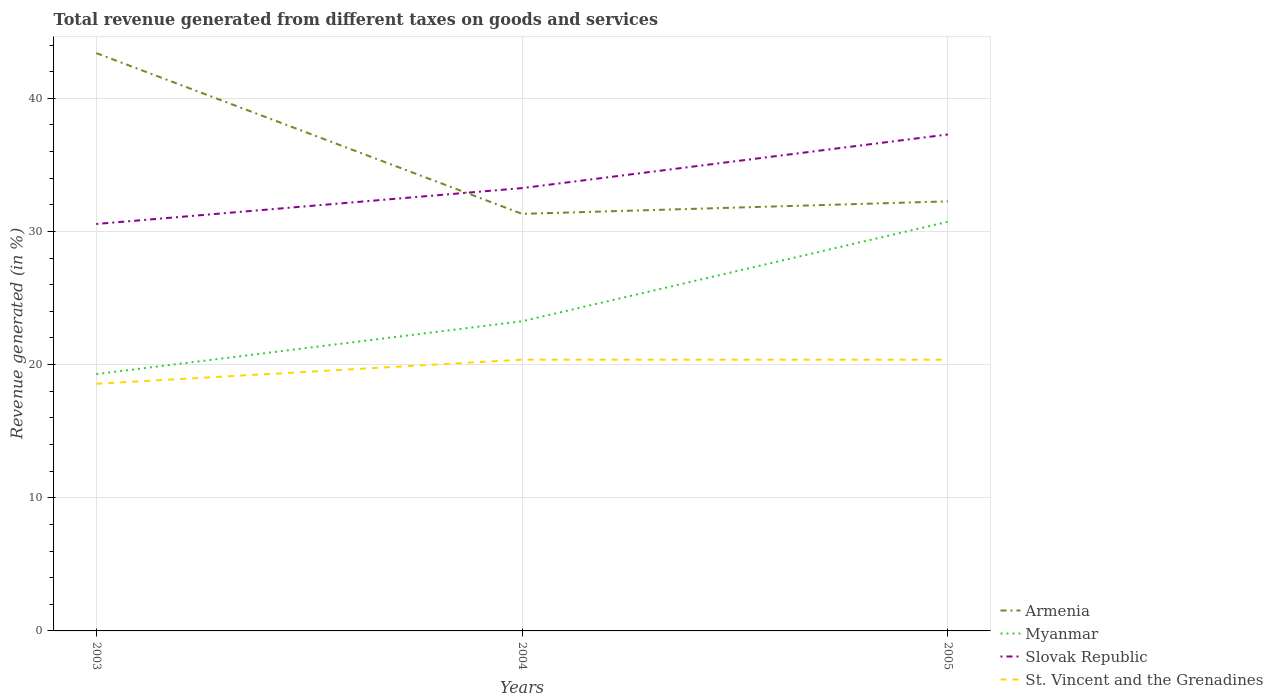Does the line corresponding to Slovak Republic intersect with the line corresponding to Myanmar?
Your response must be concise. No. Across all years, what is the maximum total revenue generated in Armenia?
Provide a succinct answer. 31.32. In which year was the total revenue generated in Myanmar maximum?
Make the answer very short. 2003. What is the total total revenue generated in Armenia in the graph?
Ensure brevity in your answer.  -0.94. What is the difference between the highest and the second highest total revenue generated in Slovak Republic?
Offer a very short reply. 6.72. What is the difference between the highest and the lowest total revenue generated in Myanmar?
Offer a terse response. 1. How many lines are there?
Ensure brevity in your answer.  4. How many years are there in the graph?
Make the answer very short. 3. Does the graph contain any zero values?
Make the answer very short. No. Where does the legend appear in the graph?
Your response must be concise. Bottom right. How are the legend labels stacked?
Offer a very short reply. Vertical. What is the title of the graph?
Provide a short and direct response. Total revenue generated from different taxes on goods and services. What is the label or title of the Y-axis?
Ensure brevity in your answer.  Revenue generated (in %). What is the Revenue generated (in %) of Armenia in 2003?
Your response must be concise. 43.39. What is the Revenue generated (in %) of Myanmar in 2003?
Keep it short and to the point. 19.29. What is the Revenue generated (in %) of Slovak Republic in 2003?
Give a very brief answer. 30.56. What is the Revenue generated (in %) in St. Vincent and the Grenadines in 2003?
Your answer should be compact. 18.56. What is the Revenue generated (in %) in Armenia in 2004?
Give a very brief answer. 31.32. What is the Revenue generated (in %) of Myanmar in 2004?
Your answer should be compact. 23.26. What is the Revenue generated (in %) in Slovak Republic in 2004?
Provide a short and direct response. 33.26. What is the Revenue generated (in %) in St. Vincent and the Grenadines in 2004?
Ensure brevity in your answer.  20.37. What is the Revenue generated (in %) in Armenia in 2005?
Your response must be concise. 32.26. What is the Revenue generated (in %) of Myanmar in 2005?
Offer a very short reply. 30.73. What is the Revenue generated (in %) in Slovak Republic in 2005?
Offer a very short reply. 37.28. What is the Revenue generated (in %) in St. Vincent and the Grenadines in 2005?
Offer a terse response. 20.37. Across all years, what is the maximum Revenue generated (in %) in Armenia?
Provide a succinct answer. 43.39. Across all years, what is the maximum Revenue generated (in %) of Myanmar?
Make the answer very short. 30.73. Across all years, what is the maximum Revenue generated (in %) in Slovak Republic?
Your answer should be compact. 37.28. Across all years, what is the maximum Revenue generated (in %) of St. Vincent and the Grenadines?
Provide a short and direct response. 20.37. Across all years, what is the minimum Revenue generated (in %) in Armenia?
Ensure brevity in your answer.  31.32. Across all years, what is the minimum Revenue generated (in %) in Myanmar?
Offer a terse response. 19.29. Across all years, what is the minimum Revenue generated (in %) in Slovak Republic?
Your answer should be very brief. 30.56. Across all years, what is the minimum Revenue generated (in %) of St. Vincent and the Grenadines?
Provide a short and direct response. 18.56. What is the total Revenue generated (in %) of Armenia in the graph?
Your answer should be very brief. 106.98. What is the total Revenue generated (in %) in Myanmar in the graph?
Your response must be concise. 73.27. What is the total Revenue generated (in %) in Slovak Republic in the graph?
Provide a short and direct response. 101.1. What is the total Revenue generated (in %) of St. Vincent and the Grenadines in the graph?
Your response must be concise. 59.3. What is the difference between the Revenue generated (in %) in Armenia in 2003 and that in 2004?
Keep it short and to the point. 12.07. What is the difference between the Revenue generated (in %) of Myanmar in 2003 and that in 2004?
Your answer should be very brief. -3.97. What is the difference between the Revenue generated (in %) of Slovak Republic in 2003 and that in 2004?
Your answer should be compact. -2.7. What is the difference between the Revenue generated (in %) of St. Vincent and the Grenadines in 2003 and that in 2004?
Ensure brevity in your answer.  -1.81. What is the difference between the Revenue generated (in %) of Armenia in 2003 and that in 2005?
Give a very brief answer. 11.13. What is the difference between the Revenue generated (in %) of Myanmar in 2003 and that in 2005?
Ensure brevity in your answer.  -11.44. What is the difference between the Revenue generated (in %) of Slovak Republic in 2003 and that in 2005?
Provide a short and direct response. -6.72. What is the difference between the Revenue generated (in %) of St. Vincent and the Grenadines in 2003 and that in 2005?
Give a very brief answer. -1.81. What is the difference between the Revenue generated (in %) in Armenia in 2004 and that in 2005?
Make the answer very short. -0.94. What is the difference between the Revenue generated (in %) of Myanmar in 2004 and that in 2005?
Provide a short and direct response. -7.47. What is the difference between the Revenue generated (in %) in Slovak Republic in 2004 and that in 2005?
Offer a terse response. -4.03. What is the difference between the Revenue generated (in %) in St. Vincent and the Grenadines in 2004 and that in 2005?
Make the answer very short. 0. What is the difference between the Revenue generated (in %) of Armenia in 2003 and the Revenue generated (in %) of Myanmar in 2004?
Make the answer very short. 20.14. What is the difference between the Revenue generated (in %) of Armenia in 2003 and the Revenue generated (in %) of Slovak Republic in 2004?
Your answer should be very brief. 10.14. What is the difference between the Revenue generated (in %) in Armenia in 2003 and the Revenue generated (in %) in St. Vincent and the Grenadines in 2004?
Offer a terse response. 23.02. What is the difference between the Revenue generated (in %) of Myanmar in 2003 and the Revenue generated (in %) of Slovak Republic in 2004?
Ensure brevity in your answer.  -13.97. What is the difference between the Revenue generated (in %) of Myanmar in 2003 and the Revenue generated (in %) of St. Vincent and the Grenadines in 2004?
Your answer should be compact. -1.08. What is the difference between the Revenue generated (in %) of Slovak Republic in 2003 and the Revenue generated (in %) of St. Vincent and the Grenadines in 2004?
Provide a short and direct response. 10.19. What is the difference between the Revenue generated (in %) of Armenia in 2003 and the Revenue generated (in %) of Myanmar in 2005?
Offer a very short reply. 12.67. What is the difference between the Revenue generated (in %) in Armenia in 2003 and the Revenue generated (in %) in Slovak Republic in 2005?
Your response must be concise. 6.11. What is the difference between the Revenue generated (in %) in Armenia in 2003 and the Revenue generated (in %) in St. Vincent and the Grenadines in 2005?
Make the answer very short. 23.02. What is the difference between the Revenue generated (in %) of Myanmar in 2003 and the Revenue generated (in %) of Slovak Republic in 2005?
Your answer should be very brief. -18. What is the difference between the Revenue generated (in %) in Myanmar in 2003 and the Revenue generated (in %) in St. Vincent and the Grenadines in 2005?
Make the answer very short. -1.08. What is the difference between the Revenue generated (in %) in Slovak Republic in 2003 and the Revenue generated (in %) in St. Vincent and the Grenadines in 2005?
Your answer should be compact. 10.19. What is the difference between the Revenue generated (in %) of Armenia in 2004 and the Revenue generated (in %) of Myanmar in 2005?
Provide a succinct answer. 0.59. What is the difference between the Revenue generated (in %) of Armenia in 2004 and the Revenue generated (in %) of Slovak Republic in 2005?
Offer a very short reply. -5.96. What is the difference between the Revenue generated (in %) of Armenia in 2004 and the Revenue generated (in %) of St. Vincent and the Grenadines in 2005?
Make the answer very short. 10.95. What is the difference between the Revenue generated (in %) of Myanmar in 2004 and the Revenue generated (in %) of Slovak Republic in 2005?
Your response must be concise. -14.03. What is the difference between the Revenue generated (in %) in Myanmar in 2004 and the Revenue generated (in %) in St. Vincent and the Grenadines in 2005?
Make the answer very short. 2.89. What is the difference between the Revenue generated (in %) in Slovak Republic in 2004 and the Revenue generated (in %) in St. Vincent and the Grenadines in 2005?
Keep it short and to the point. 12.89. What is the average Revenue generated (in %) in Armenia per year?
Provide a short and direct response. 35.66. What is the average Revenue generated (in %) of Myanmar per year?
Give a very brief answer. 24.42. What is the average Revenue generated (in %) in Slovak Republic per year?
Give a very brief answer. 33.7. What is the average Revenue generated (in %) of St. Vincent and the Grenadines per year?
Provide a short and direct response. 19.77. In the year 2003, what is the difference between the Revenue generated (in %) of Armenia and Revenue generated (in %) of Myanmar?
Your answer should be very brief. 24.11. In the year 2003, what is the difference between the Revenue generated (in %) in Armenia and Revenue generated (in %) in Slovak Republic?
Provide a succinct answer. 12.83. In the year 2003, what is the difference between the Revenue generated (in %) of Armenia and Revenue generated (in %) of St. Vincent and the Grenadines?
Your answer should be compact. 24.83. In the year 2003, what is the difference between the Revenue generated (in %) of Myanmar and Revenue generated (in %) of Slovak Republic?
Provide a short and direct response. -11.27. In the year 2003, what is the difference between the Revenue generated (in %) of Myanmar and Revenue generated (in %) of St. Vincent and the Grenadines?
Give a very brief answer. 0.73. In the year 2003, what is the difference between the Revenue generated (in %) in Slovak Republic and Revenue generated (in %) in St. Vincent and the Grenadines?
Give a very brief answer. 12. In the year 2004, what is the difference between the Revenue generated (in %) in Armenia and Revenue generated (in %) in Myanmar?
Make the answer very short. 8.06. In the year 2004, what is the difference between the Revenue generated (in %) in Armenia and Revenue generated (in %) in Slovak Republic?
Your answer should be very brief. -1.94. In the year 2004, what is the difference between the Revenue generated (in %) in Armenia and Revenue generated (in %) in St. Vincent and the Grenadines?
Provide a succinct answer. 10.95. In the year 2004, what is the difference between the Revenue generated (in %) in Myanmar and Revenue generated (in %) in Slovak Republic?
Your answer should be compact. -10. In the year 2004, what is the difference between the Revenue generated (in %) of Myanmar and Revenue generated (in %) of St. Vincent and the Grenadines?
Provide a short and direct response. 2.88. In the year 2004, what is the difference between the Revenue generated (in %) in Slovak Republic and Revenue generated (in %) in St. Vincent and the Grenadines?
Offer a very short reply. 12.88. In the year 2005, what is the difference between the Revenue generated (in %) of Armenia and Revenue generated (in %) of Myanmar?
Offer a very short reply. 1.53. In the year 2005, what is the difference between the Revenue generated (in %) of Armenia and Revenue generated (in %) of Slovak Republic?
Offer a very short reply. -5.02. In the year 2005, what is the difference between the Revenue generated (in %) of Armenia and Revenue generated (in %) of St. Vincent and the Grenadines?
Make the answer very short. 11.89. In the year 2005, what is the difference between the Revenue generated (in %) of Myanmar and Revenue generated (in %) of Slovak Republic?
Your answer should be very brief. -6.56. In the year 2005, what is the difference between the Revenue generated (in %) of Myanmar and Revenue generated (in %) of St. Vincent and the Grenadines?
Provide a succinct answer. 10.36. In the year 2005, what is the difference between the Revenue generated (in %) of Slovak Republic and Revenue generated (in %) of St. Vincent and the Grenadines?
Offer a very short reply. 16.91. What is the ratio of the Revenue generated (in %) of Armenia in 2003 to that in 2004?
Provide a short and direct response. 1.39. What is the ratio of the Revenue generated (in %) of Myanmar in 2003 to that in 2004?
Offer a very short reply. 0.83. What is the ratio of the Revenue generated (in %) in Slovak Republic in 2003 to that in 2004?
Your response must be concise. 0.92. What is the ratio of the Revenue generated (in %) of St. Vincent and the Grenadines in 2003 to that in 2004?
Make the answer very short. 0.91. What is the ratio of the Revenue generated (in %) of Armenia in 2003 to that in 2005?
Give a very brief answer. 1.35. What is the ratio of the Revenue generated (in %) of Myanmar in 2003 to that in 2005?
Your answer should be compact. 0.63. What is the ratio of the Revenue generated (in %) in Slovak Republic in 2003 to that in 2005?
Your answer should be compact. 0.82. What is the ratio of the Revenue generated (in %) in St. Vincent and the Grenadines in 2003 to that in 2005?
Your response must be concise. 0.91. What is the ratio of the Revenue generated (in %) in Armenia in 2004 to that in 2005?
Give a very brief answer. 0.97. What is the ratio of the Revenue generated (in %) of Myanmar in 2004 to that in 2005?
Give a very brief answer. 0.76. What is the ratio of the Revenue generated (in %) in Slovak Republic in 2004 to that in 2005?
Keep it short and to the point. 0.89. What is the ratio of the Revenue generated (in %) in St. Vincent and the Grenadines in 2004 to that in 2005?
Give a very brief answer. 1. What is the difference between the highest and the second highest Revenue generated (in %) of Armenia?
Offer a terse response. 11.13. What is the difference between the highest and the second highest Revenue generated (in %) in Myanmar?
Your answer should be very brief. 7.47. What is the difference between the highest and the second highest Revenue generated (in %) of Slovak Republic?
Ensure brevity in your answer.  4.03. What is the difference between the highest and the second highest Revenue generated (in %) of St. Vincent and the Grenadines?
Make the answer very short. 0. What is the difference between the highest and the lowest Revenue generated (in %) in Armenia?
Ensure brevity in your answer.  12.07. What is the difference between the highest and the lowest Revenue generated (in %) in Myanmar?
Give a very brief answer. 11.44. What is the difference between the highest and the lowest Revenue generated (in %) in Slovak Republic?
Keep it short and to the point. 6.72. What is the difference between the highest and the lowest Revenue generated (in %) of St. Vincent and the Grenadines?
Your response must be concise. 1.81. 